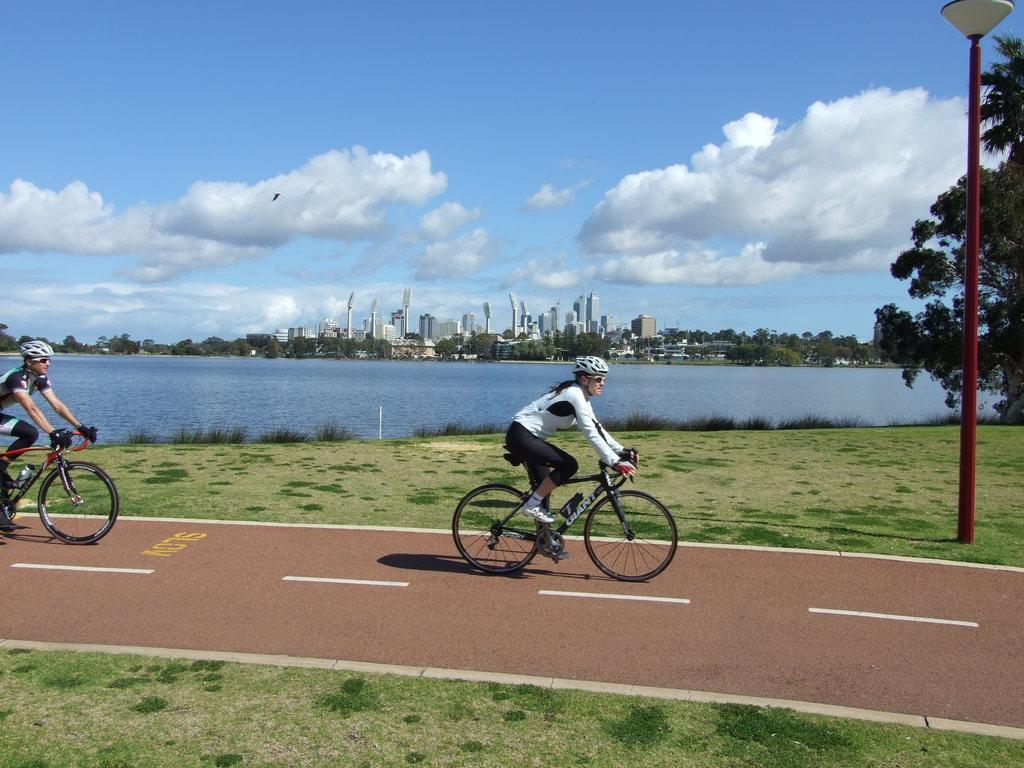Can you describe this image briefly? In this picture I can see two persons riding the bicycles, there is grass, a pole, a light, there is water, there are plants, trees, buildings, and in the background there is sky. 